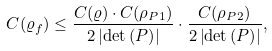<formula> <loc_0><loc_0><loc_500><loc_500>C ( \varrho _ { f } ) \leq \frac { C ( \varrho ) \cdot C ( \rho _ { P 1 } ) } { 2 \left | \det \left ( P \right ) \right | } \cdot \frac { C ( \rho _ { P 2 } ) } { 2 \left | \det \left ( P \right ) \right | } ,</formula> 